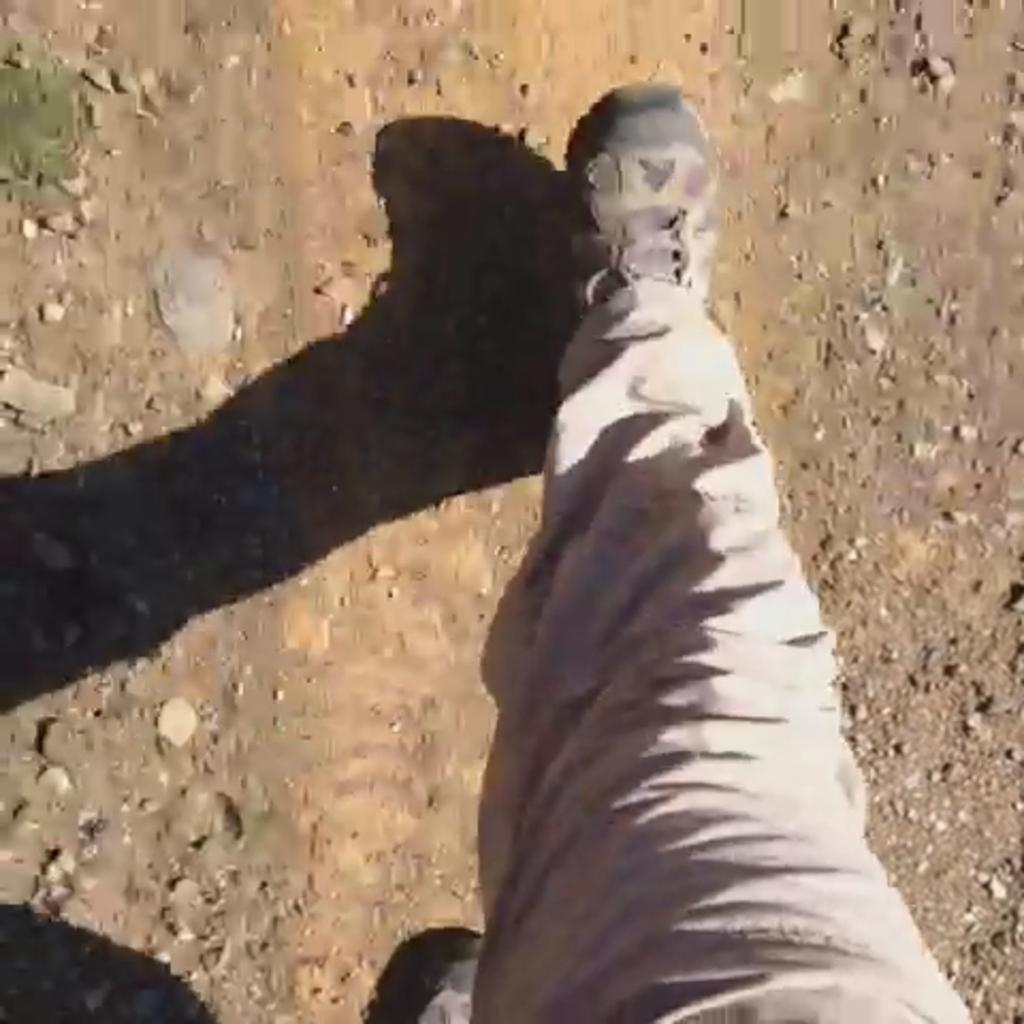What is present in the image? There is a person in the image. What is the person doing in the image? The person is walking. What type of brick is being used to build the coil in the image? There is no brick or coil present in the image; it features a person walking. How many drops of water can be seen falling from the sky in the image? There are no drops of water visible in the image. 